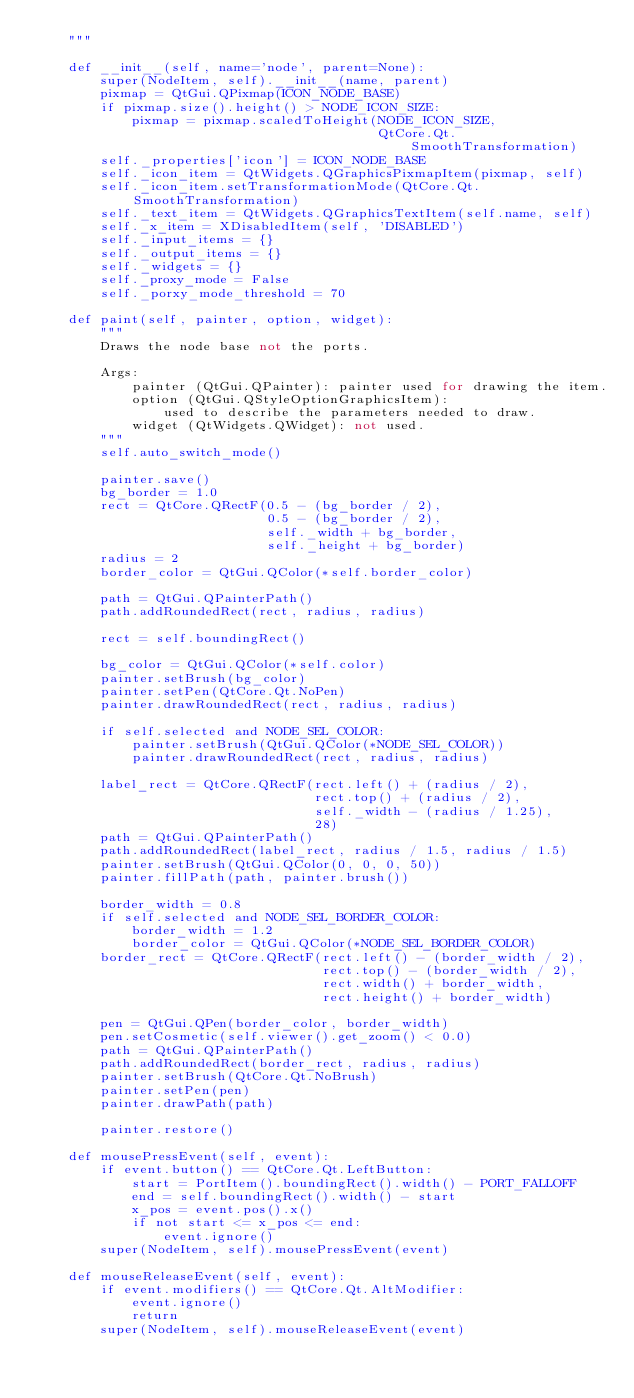<code> <loc_0><loc_0><loc_500><loc_500><_Python_>    """

    def __init__(self, name='node', parent=None):
        super(NodeItem, self).__init__(name, parent)
        pixmap = QtGui.QPixmap(ICON_NODE_BASE)
        if pixmap.size().height() > NODE_ICON_SIZE:
            pixmap = pixmap.scaledToHeight(NODE_ICON_SIZE,
                                           QtCore.Qt.SmoothTransformation)
        self._properties['icon'] = ICON_NODE_BASE
        self._icon_item = QtWidgets.QGraphicsPixmapItem(pixmap, self)
        self._icon_item.setTransformationMode(QtCore.Qt.SmoothTransformation)
        self._text_item = QtWidgets.QGraphicsTextItem(self.name, self)
        self._x_item = XDisabledItem(self, 'DISABLED')
        self._input_items = {}
        self._output_items = {}
        self._widgets = {}
        self._proxy_mode = False
        self._porxy_mode_threshold = 70

    def paint(self, painter, option, widget):
        """
        Draws the node base not the ports.

        Args:
            painter (QtGui.QPainter): painter used for drawing the item.
            option (QtGui.QStyleOptionGraphicsItem):
                used to describe the parameters needed to draw.
            widget (QtWidgets.QWidget): not used.
        """
        self.auto_switch_mode()

        painter.save()
        bg_border = 1.0
        rect = QtCore.QRectF(0.5 - (bg_border / 2),
                             0.5 - (bg_border / 2),
                             self._width + bg_border,
                             self._height + bg_border)
        radius = 2
        border_color = QtGui.QColor(*self.border_color)

        path = QtGui.QPainterPath()
        path.addRoundedRect(rect, radius, radius)

        rect = self.boundingRect()

        bg_color = QtGui.QColor(*self.color)
        painter.setBrush(bg_color)
        painter.setPen(QtCore.Qt.NoPen)
        painter.drawRoundedRect(rect, radius, radius)

        if self.selected and NODE_SEL_COLOR:
            painter.setBrush(QtGui.QColor(*NODE_SEL_COLOR))
            painter.drawRoundedRect(rect, radius, radius)

        label_rect = QtCore.QRectF(rect.left() + (radius / 2),
                                   rect.top() + (radius / 2),
                                   self._width - (radius / 1.25),
                                   28)
        path = QtGui.QPainterPath()
        path.addRoundedRect(label_rect, radius / 1.5, radius / 1.5)
        painter.setBrush(QtGui.QColor(0, 0, 0, 50))
        painter.fillPath(path, painter.brush())

        border_width = 0.8
        if self.selected and NODE_SEL_BORDER_COLOR:
            border_width = 1.2
            border_color = QtGui.QColor(*NODE_SEL_BORDER_COLOR)
        border_rect = QtCore.QRectF(rect.left() - (border_width / 2),
                                    rect.top() - (border_width / 2),
                                    rect.width() + border_width,
                                    rect.height() + border_width)

        pen = QtGui.QPen(border_color, border_width)
        pen.setCosmetic(self.viewer().get_zoom() < 0.0)
        path = QtGui.QPainterPath()
        path.addRoundedRect(border_rect, radius, radius)
        painter.setBrush(QtCore.Qt.NoBrush)
        painter.setPen(pen)
        painter.drawPath(path)

        painter.restore()

    def mousePressEvent(self, event):
        if event.button() == QtCore.Qt.LeftButton:
            start = PortItem().boundingRect().width() - PORT_FALLOFF
            end = self.boundingRect().width() - start
            x_pos = event.pos().x()
            if not start <= x_pos <= end:
                event.ignore()
        super(NodeItem, self).mousePressEvent(event)

    def mouseReleaseEvent(self, event):
        if event.modifiers() == QtCore.Qt.AltModifier:
            event.ignore()
            return
        super(NodeItem, self).mouseReleaseEvent(event)
</code> 